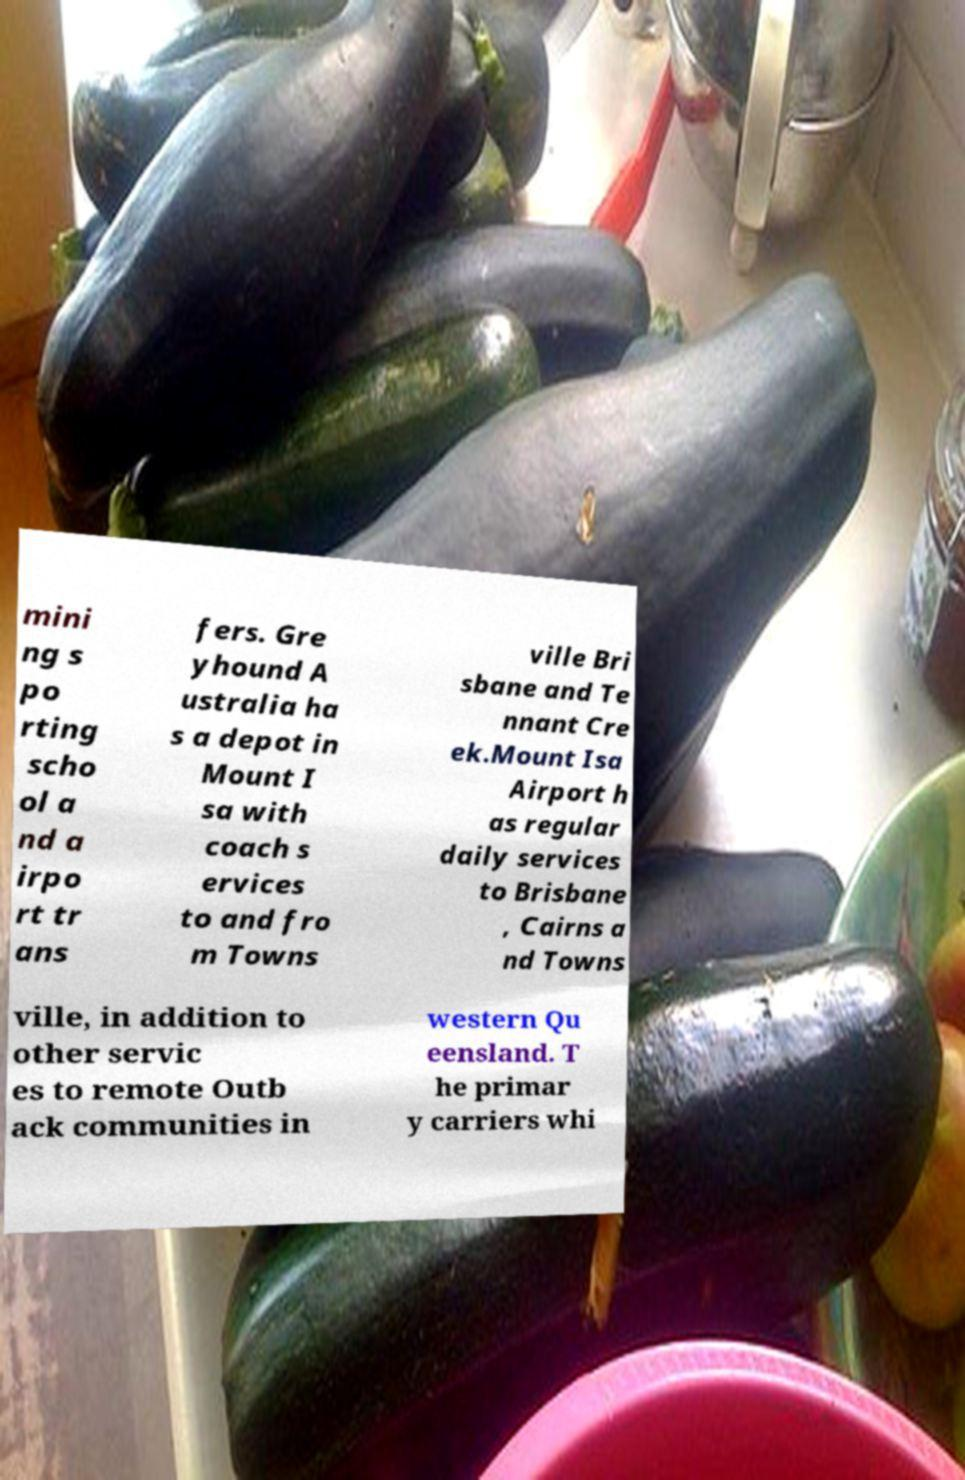Can you read and provide the text displayed in the image?This photo seems to have some interesting text. Can you extract and type it out for me? mini ng s po rting scho ol a nd a irpo rt tr ans fers. Gre yhound A ustralia ha s a depot in Mount I sa with coach s ervices to and fro m Towns ville Bri sbane and Te nnant Cre ek.Mount Isa Airport h as regular daily services to Brisbane , Cairns a nd Towns ville, in addition to other servic es to remote Outb ack communities in western Qu eensland. T he primar y carriers whi 